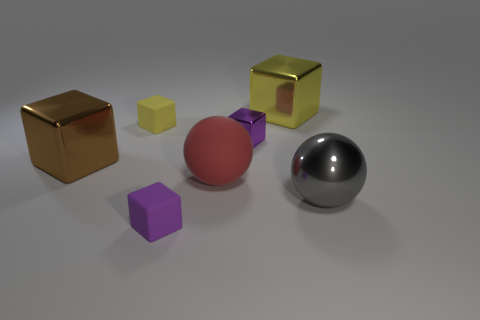Subtract all green balls. Subtract all gray cylinders. How many balls are left? 2 Add 2 metallic things. How many objects exist? 9 Subtract all blocks. How many objects are left? 2 Subtract 0 purple spheres. How many objects are left? 7 Subtract all tiny purple metallic spheres. Subtract all yellow cubes. How many objects are left? 5 Add 7 yellow metallic objects. How many yellow metallic objects are left? 8 Add 1 red spheres. How many red spheres exist? 2 